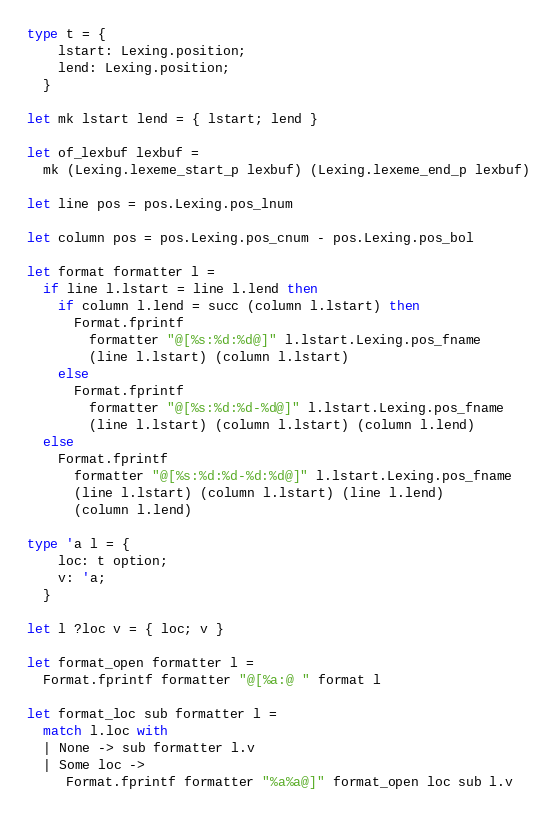Convert code to text. <code><loc_0><loc_0><loc_500><loc_500><_OCaml_>type t = {
    lstart: Lexing.position;
    lend: Lexing.position;
  }

let mk lstart lend = { lstart; lend }

let of_lexbuf lexbuf =
  mk (Lexing.lexeme_start_p lexbuf) (Lexing.lexeme_end_p lexbuf)

let line pos = pos.Lexing.pos_lnum

let column pos = pos.Lexing.pos_cnum - pos.Lexing.pos_bol

let format formatter l =
  if line l.lstart = line l.lend then
    if column l.lend = succ (column l.lstart) then
      Format.fprintf
        formatter "@[%s:%d:%d@]" l.lstart.Lexing.pos_fname
        (line l.lstart) (column l.lstart)
    else
      Format.fprintf
        formatter "@[%s:%d:%d-%d@]" l.lstart.Lexing.pos_fname
        (line l.lstart) (column l.lstart) (column l.lend)
  else
    Format.fprintf
      formatter "@[%s:%d:%d-%d:%d@]" l.lstart.Lexing.pos_fname
      (line l.lstart) (column l.lstart) (line l.lend)
      (column l.lend)

type 'a l = {
    loc: t option;
    v: 'a;
  }

let l ?loc v = { loc; v }

let format_open formatter l =
  Format.fprintf formatter "@[%a:@ " format l

let format_loc sub formatter l =
  match l.loc with
  | None -> sub formatter l.v
  | Some loc ->
     Format.fprintf formatter "%a%a@]" format_open loc sub l.v
</code> 